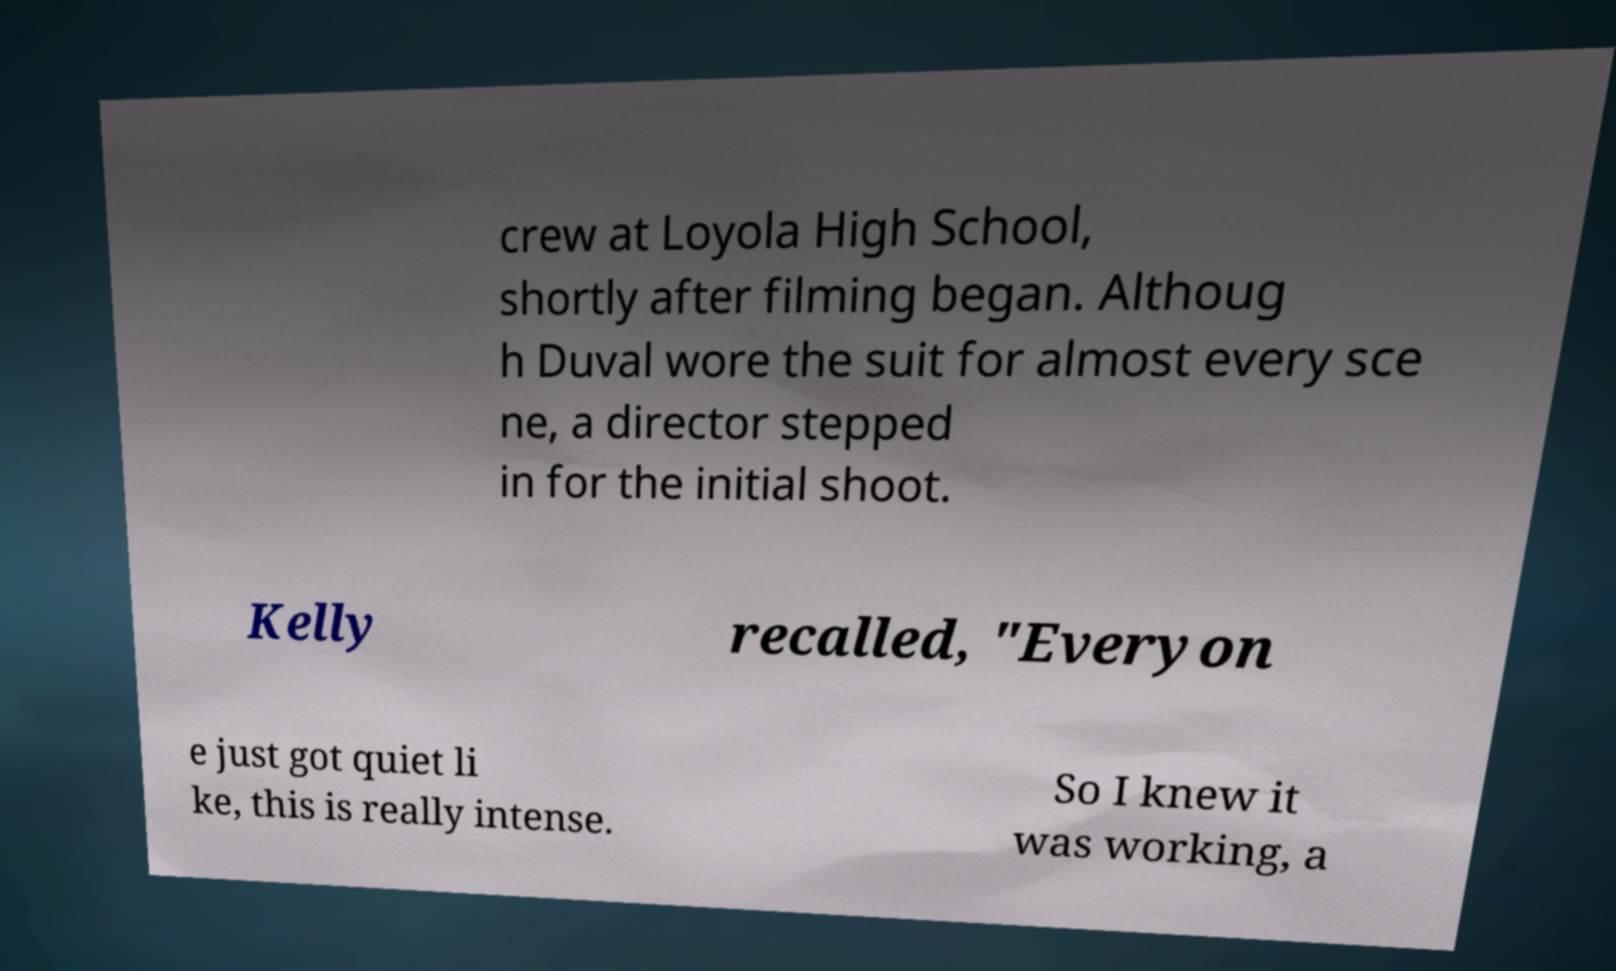There's text embedded in this image that I need extracted. Can you transcribe it verbatim? crew at Loyola High School, shortly after filming began. Althoug h Duval wore the suit for almost every sce ne, a director stepped in for the initial shoot. Kelly recalled, "Everyon e just got quiet li ke, this is really intense. So I knew it was working, a 